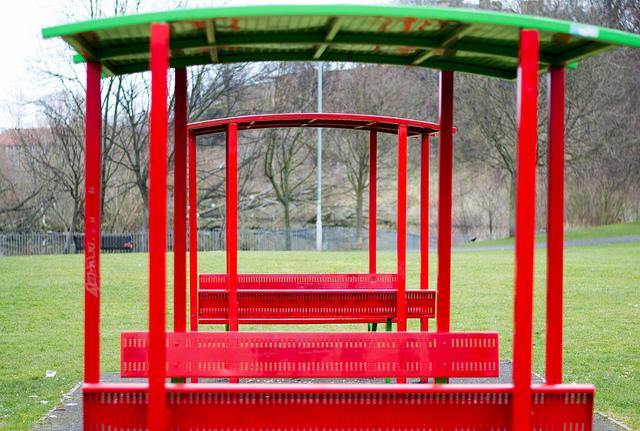What can be seen in the background from the red benches?
Concise answer only. Trees. Is it summertime?
Be succinct. No. What color is the bench roof?
Keep it brief. Green. 